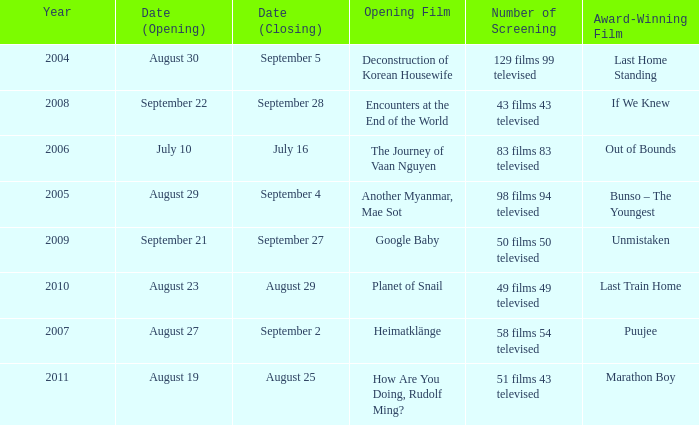Which opening film has the opening date of august 23? Planet of Snail. 